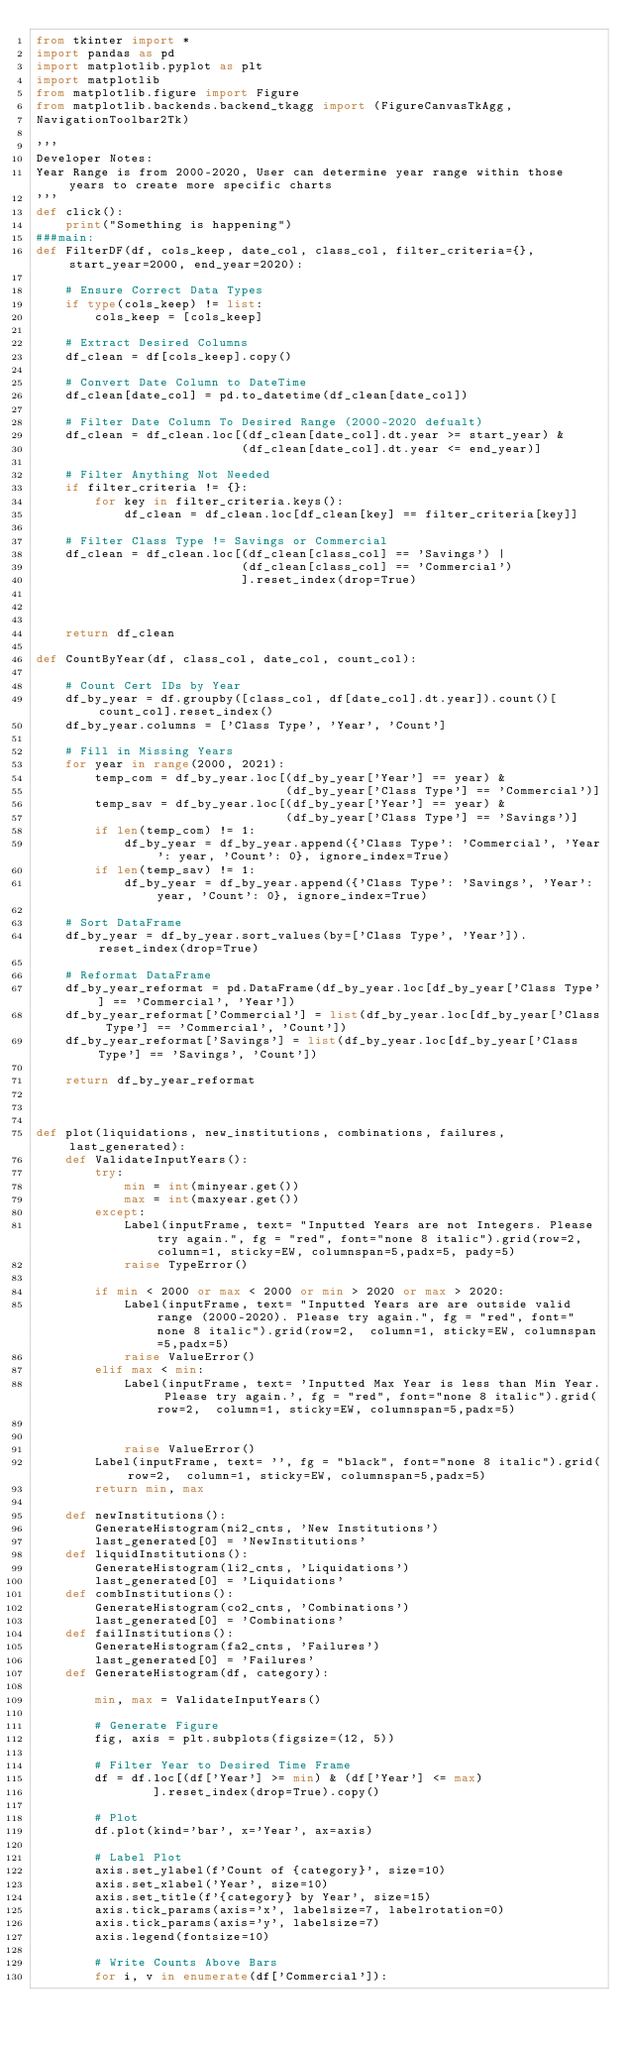<code> <loc_0><loc_0><loc_500><loc_500><_Python_>from tkinter import *
import pandas as pd
import matplotlib.pyplot as plt
import matplotlib
from matplotlib.figure import Figure
from matplotlib.backends.backend_tkagg import (FigureCanvasTkAgg, 
NavigationToolbar2Tk)

'''
Developer Notes: 
Year Range is from 2000-2020, User can determine year range within those years to create more specific charts
'''
def click():
    print("Something is happening")
###main:
def FilterDF(df, cols_keep, date_col, class_col, filter_criteria={}, start_year=2000, end_year=2020):

    # Ensure Correct Data Types
    if type(cols_keep) != list:
        cols_keep = [cols_keep]

    # Extract Desired Columns
    df_clean = df[cols_keep].copy()
    
    # Convert Date Column to DateTime
    df_clean[date_col] = pd.to_datetime(df_clean[date_col])

    # Filter Date Column To Desired Range (2000-2020 defualt)
    df_clean = df_clean.loc[(df_clean[date_col].dt.year >= start_year) & 
                            (df_clean[date_col].dt.year <= end_year)]

    # Filter Anything Not Needed
    if filter_criteria != {}:
        for key in filter_criteria.keys():
            df_clean = df_clean.loc[df_clean[key] == filter_criteria[key]]

    # Filter Class Type != Savings or Commercial
    df_clean = df_clean.loc[(df_clean[class_col] == 'Savings') |
                            (df_clean[class_col] == 'Commercial')
                            ].reset_index(drop=True)

    

    return df_clean

def CountByYear(df, class_col, date_col, count_col):

    # Count Cert IDs by Year
    df_by_year = df.groupby([class_col, df[date_col].dt.year]).count()[count_col].reset_index()
    df_by_year.columns = ['Class Type', 'Year', 'Count']

    # Fill in Missing Years
    for year in range(2000, 2021):
        temp_com = df_by_year.loc[(df_by_year['Year'] == year) &
                                  (df_by_year['Class Type'] == 'Commercial')]
        temp_sav = df_by_year.loc[(df_by_year['Year'] == year) &
                                  (df_by_year['Class Type'] == 'Savings')]
        if len(temp_com) != 1:
            df_by_year = df_by_year.append({'Class Type': 'Commercial', 'Year': year, 'Count': 0}, ignore_index=True)
        if len(temp_sav) != 1:
            df_by_year = df_by_year.append({'Class Type': 'Savings', 'Year': year, 'Count': 0}, ignore_index=True)

    # Sort DataFrame
    df_by_year = df_by_year.sort_values(by=['Class Type', 'Year']).reset_index(drop=True)

    # Reformat DataFrame
    df_by_year_reformat = pd.DataFrame(df_by_year.loc[df_by_year['Class Type'] == 'Commercial', 'Year'])
    df_by_year_reformat['Commercial'] = list(df_by_year.loc[df_by_year['Class Type'] == 'Commercial', 'Count'])
    df_by_year_reformat['Savings'] = list(df_by_year.loc[df_by_year['Class Type'] == 'Savings', 'Count'])

    return df_by_year_reformat



def plot(liquidations, new_institutions, combinations, failures, last_generated):
    def ValidateInputYears():
        try:
            min = int(minyear.get())
            max = int(maxyear.get())
        except:
            Label(inputFrame, text= "Inputted Years are not Integers. Please try again.", fg = "red", font="none 8 italic").grid(row=2,  column=1, sticky=EW, columnspan=5,padx=5, pady=5)
            raise TypeError()

        if min < 2000 or max < 2000 or min > 2020 or max > 2020:
            Label(inputFrame, text= "Inputted Years are are outside valid range (2000-2020). Please try again.", fg = "red", font="none 8 italic").grid(row=2,  column=1, sticky=EW, columnspan=5,padx=5)
            raise ValueError()
        elif max < min:
            Label(inputFrame, text= 'Inputted Max Year is less than Min Year. Please try again.', fg = "red", font="none 8 italic").grid(row=2,  column=1, sticky=EW, columnspan=5,padx=5)

            
            raise ValueError()      
        Label(inputFrame, text= '', fg = "black", font="none 8 italic").grid(row=2,  column=1, sticky=EW, columnspan=5,padx=5)
        return min, max    
    
    def newInstitutions():
        GenerateHistogram(ni2_cnts, 'New Institutions')
        last_generated[0] = 'NewInstitutions'
    def liquidInstitutions():
        GenerateHistogram(li2_cnts, 'Liquidations')
        last_generated[0] = 'Liquidations'
    def combInstitutions():
        GenerateHistogram(co2_cnts, 'Combinations')
        last_generated[0] = 'Combinations'
    def failInstitutions():
        GenerateHistogram(fa2_cnts, 'Failures')
        last_generated[0] = 'Failures'
    def GenerateHistogram(df, category):

        min, max = ValidateInputYears()

        # Generate Figure
        fig, axis = plt.subplots(figsize=(12, 5))

        # Filter Year to Desired Time Frame
        df = df.loc[(df['Year'] >= min) & (df['Year'] <= max)
                ].reset_index(drop=True).copy()

        # Plot
        df.plot(kind='bar', x='Year', ax=axis)

        # Label Plot
        axis.set_ylabel(f'Count of {category}', size=10)
        axis.set_xlabel('Year', size=10)
        axis.set_title(f'{category} by Year', size=15)
        axis.tick_params(axis='x', labelsize=7, labelrotation=0)
        axis.tick_params(axis='y', labelsize=7)
        axis.legend(fontsize=10)

        # Write Counts Above Bars
        for i, v in enumerate(df['Commercial']):</code> 